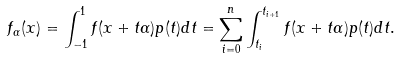<formula> <loc_0><loc_0><loc_500><loc_500>f _ { \alpha } ( x ) = \int _ { - 1 } ^ { 1 } f ( x + t \alpha ) p ( t ) d t = \sum _ { i = 0 } ^ { n } \int _ { t _ { i } } ^ { t _ { i + 1 } } f ( x + t \alpha ) p ( t ) d t .</formula> 